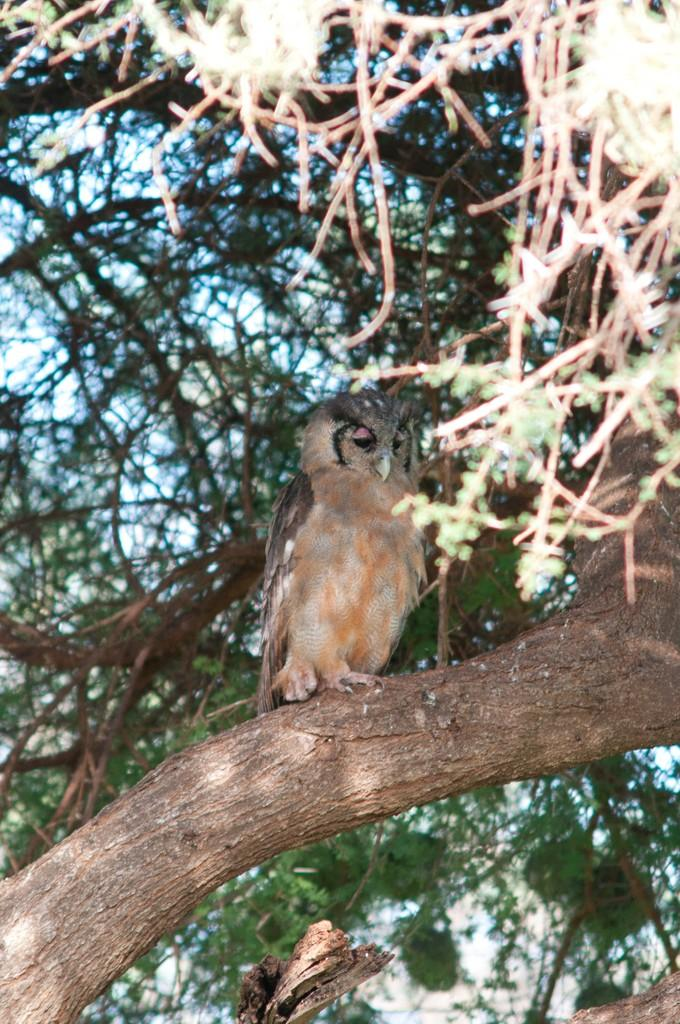What type of animal is in the image? There is an owl in the image. Where is the owl located? The owl is on a branch of a tree. What can be seen in the background of the image? There are leaves and branches in the image. What type of class is being taught in the image? There is no class or teaching activity depicted in the image; it features an owl on a tree branch. How many chess pieces can be seen on the tree branch? There are no chess pieces present in the image; it features an owl on a tree branch. 